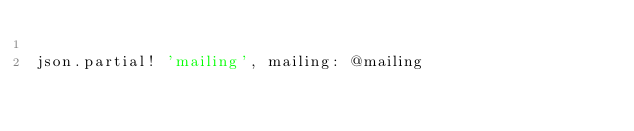Convert code to text. <code><loc_0><loc_0><loc_500><loc_500><_Ruby_>
json.partial! 'mailing', mailing: @mailing
</code> 